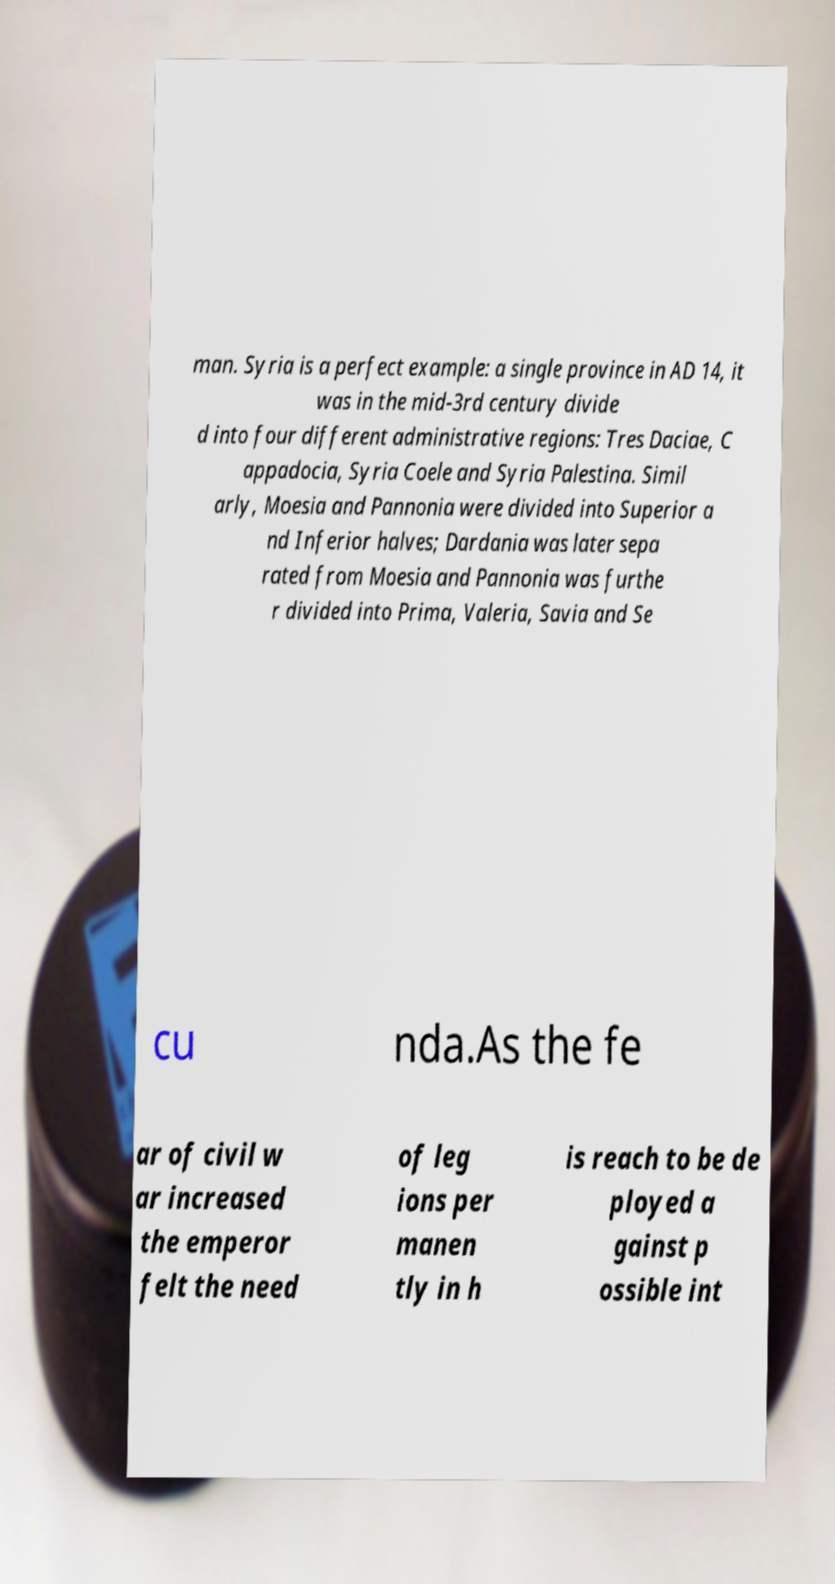Please identify and transcribe the text found in this image. man. Syria is a perfect example: a single province in AD 14, it was in the mid-3rd century divide d into four different administrative regions: Tres Daciae, C appadocia, Syria Coele and Syria Palestina. Simil arly, Moesia and Pannonia were divided into Superior a nd Inferior halves; Dardania was later sepa rated from Moesia and Pannonia was furthe r divided into Prima, Valeria, Savia and Se cu nda.As the fe ar of civil w ar increased the emperor felt the need of leg ions per manen tly in h is reach to be de ployed a gainst p ossible int 